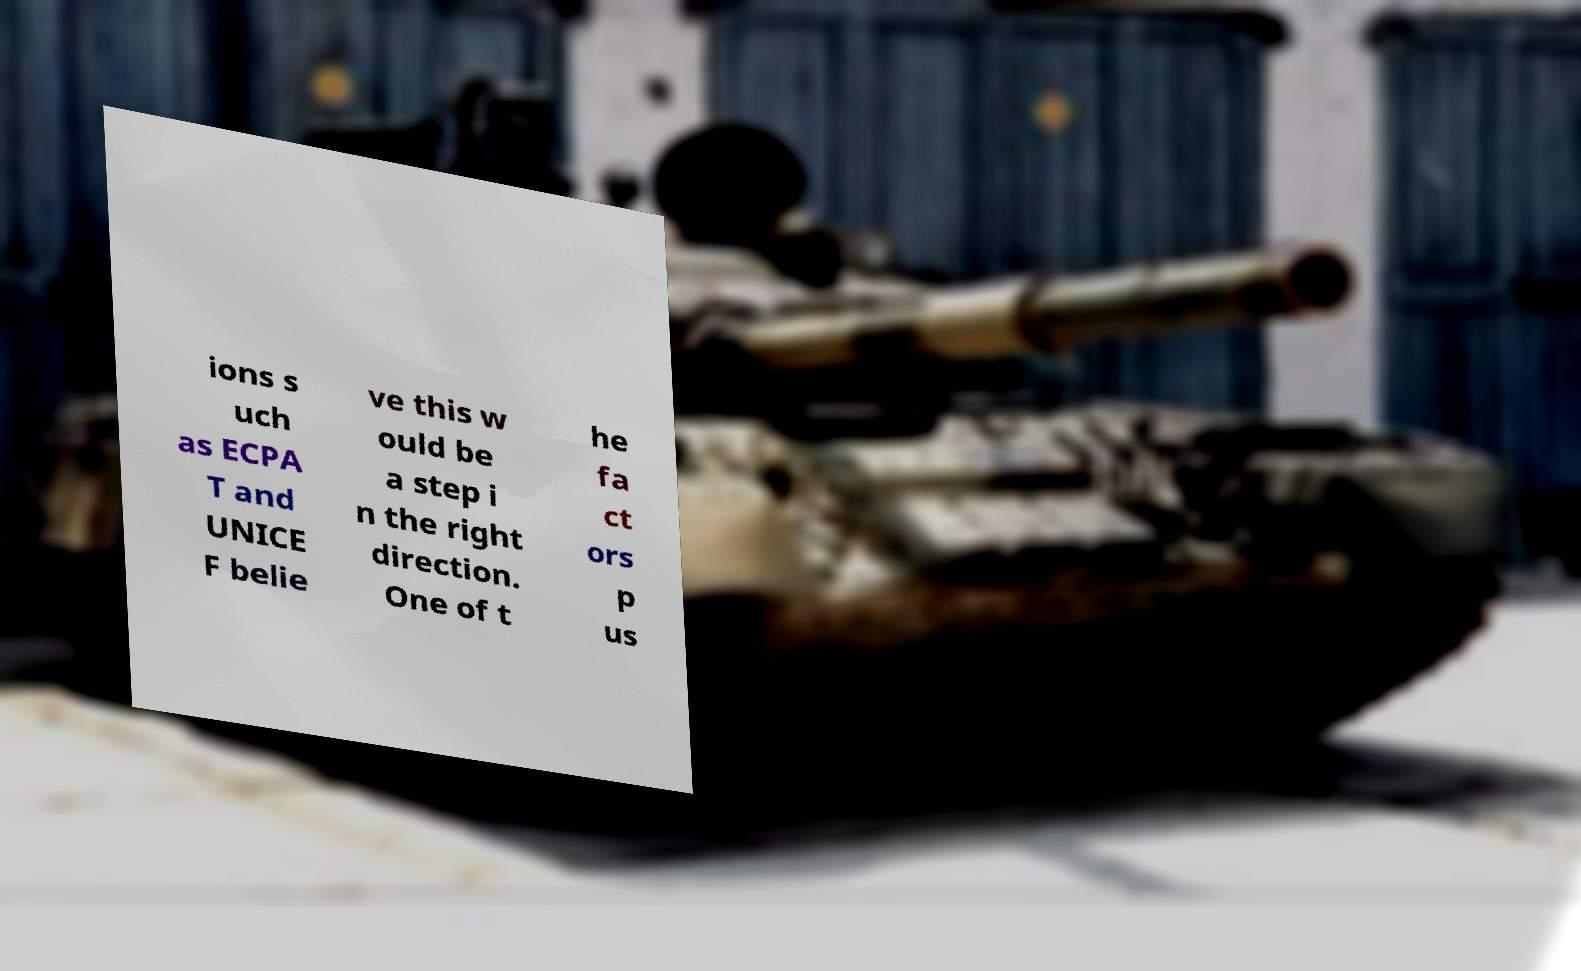I need the written content from this picture converted into text. Can you do that? ions s uch as ECPA T and UNICE F belie ve this w ould be a step i n the right direction. One of t he fa ct ors p us 